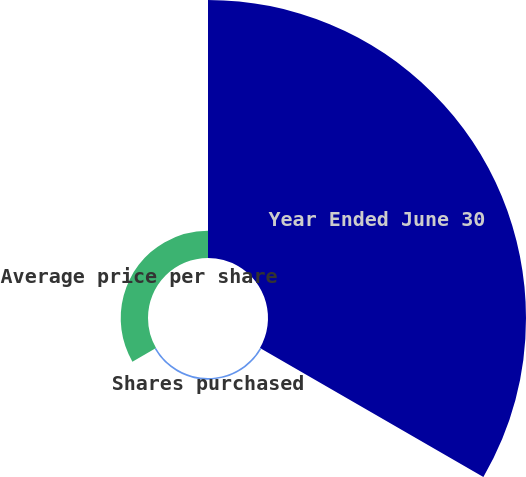Convert chart. <chart><loc_0><loc_0><loc_500><loc_500><pie_chart><fcel>Year Ended June 30<fcel>Shares purchased<fcel>Average price per share<nl><fcel>89.91%<fcel>0.58%<fcel>9.51%<nl></chart> 